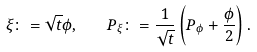Convert formula to latex. <formula><loc_0><loc_0><loc_500><loc_500>\xi \colon = \sqrt { t } \phi , \quad P _ { \xi } \colon = \frac { 1 } { \sqrt { t } } \left ( P _ { \phi } + \frac { \phi } { 2 } \right ) .</formula> 